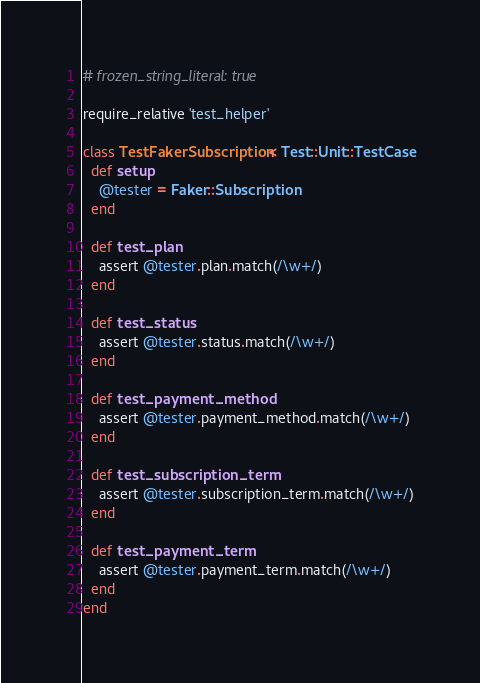Convert code to text. <code><loc_0><loc_0><loc_500><loc_500><_Ruby_># frozen_string_literal: true

require_relative 'test_helper'

class TestFakerSubscription < Test::Unit::TestCase
  def setup
    @tester = Faker::Subscription
  end

  def test_plan
    assert @tester.plan.match(/\w+/)
  end

  def test_status
    assert @tester.status.match(/\w+/)
  end

  def test_payment_method
    assert @tester.payment_method.match(/\w+/)
  end

  def test_subscription_term
    assert @tester.subscription_term.match(/\w+/)
  end

  def test_payment_term
    assert @tester.payment_term.match(/\w+/)
  end
end
</code> 